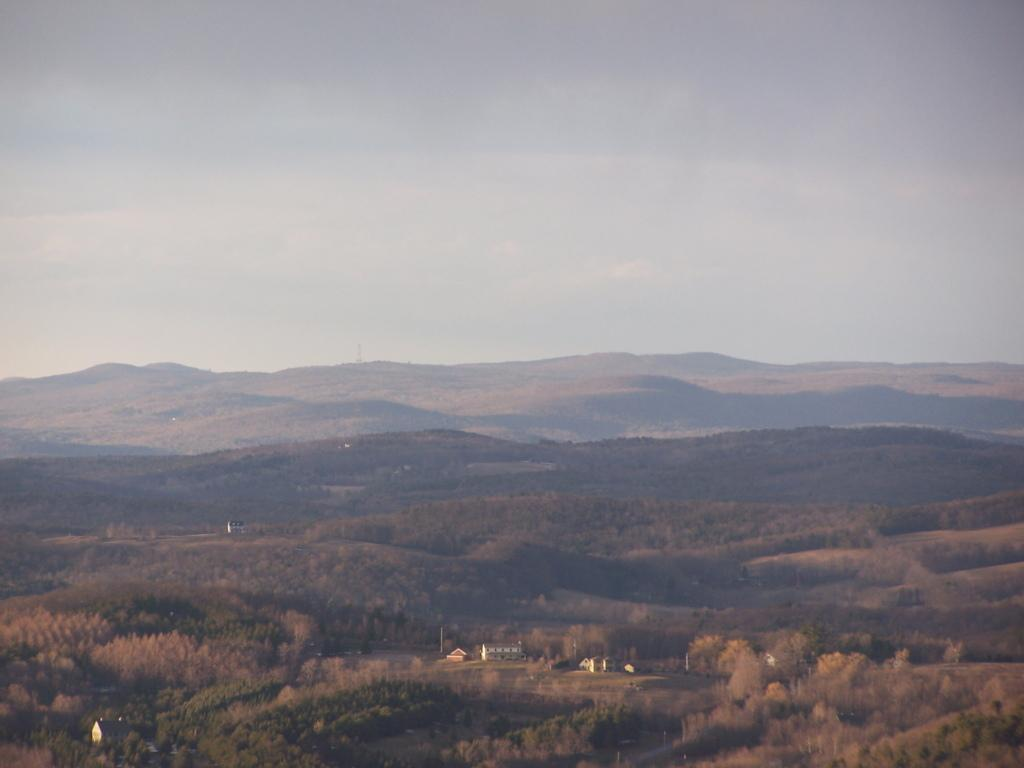What type of vegetation can be seen in the image? There are trees in the image. What structure is present in the image? There is a building in the image. What is visible at the top of the image? The sky is visible at the top of the image. What type of loaf is being used to build the structure in the image? There is no loaf present in the image; the building is made of conventional construction materials. How does the image relate to the topic of health? The image does not directly relate to the topic of health, as it primarily features trees, a building, and the sky. 